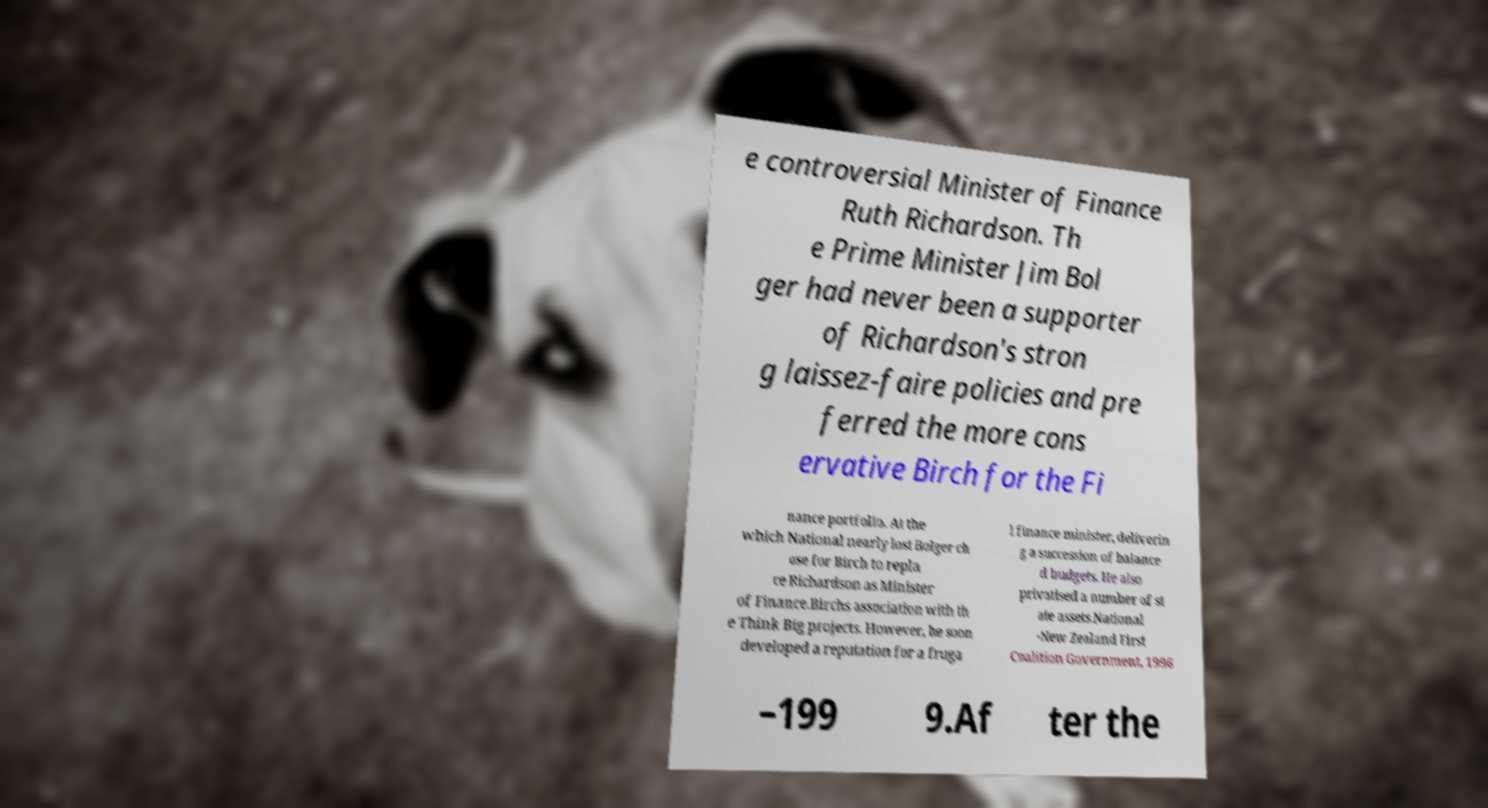Can you accurately transcribe the text from the provided image for me? e controversial Minister of Finance Ruth Richardson. Th e Prime Minister Jim Bol ger had never been a supporter of Richardson's stron g laissez-faire policies and pre ferred the more cons ervative Birch for the Fi nance portfolio. At the which National nearly lost Bolger ch ose for Birch to repla ce Richardson as Minister of Finance.Birchs association with th e Think Big projects. However, he soon developed a reputation for a fruga l finance minister, deliverin g a succession of balance d budgets. He also privatised a number of st ate assets.National -New Zealand First Coalition Government, 1996 –199 9.Af ter the 